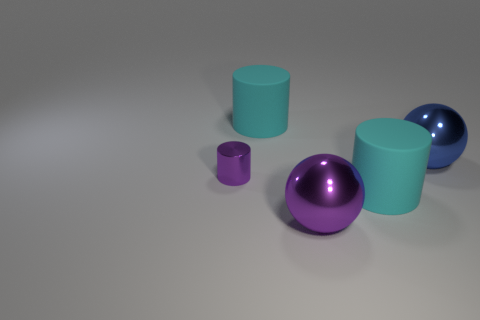Subtract all shiny cylinders. How many cylinders are left? 2 Subtract all cyan blocks. How many cyan cylinders are left? 2 Add 1 blue metal things. How many objects exist? 6 Subtract all spheres. How many objects are left? 3 Subtract all red balls. Subtract all purple cylinders. How many balls are left? 2 Subtract all small brown blocks. Subtract all metal things. How many objects are left? 2 Add 2 tiny metallic objects. How many tiny metallic objects are left? 3 Add 4 tiny yellow metal cylinders. How many tiny yellow metal cylinders exist? 4 Subtract 1 blue balls. How many objects are left? 4 